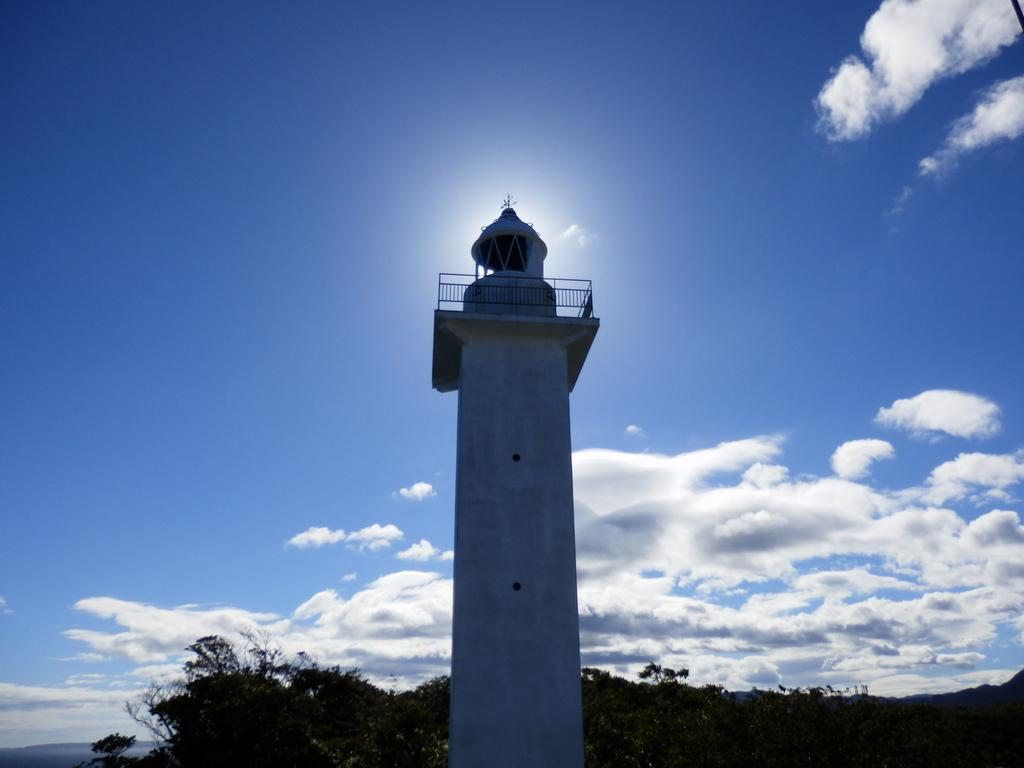What is the main structure in the image? There is a huge tower in the image. What color is the tower? The tower is white in color. What part of the tower is visible in the image? The railing is visible in the image. What type of vegetation can be seen in the image? There are green trees in the image. What is visible in the background of the image? The sky is visible in the background of the image. How many boats are docked near the tower in the image? There are no boats present in the image; it only features a tower, railing, trees, and the sky. What type of measuring device is used to determine the height of the tower in the image? There is no measuring device visible in the image, and the height of the tower cannot be determined from the image alone. 